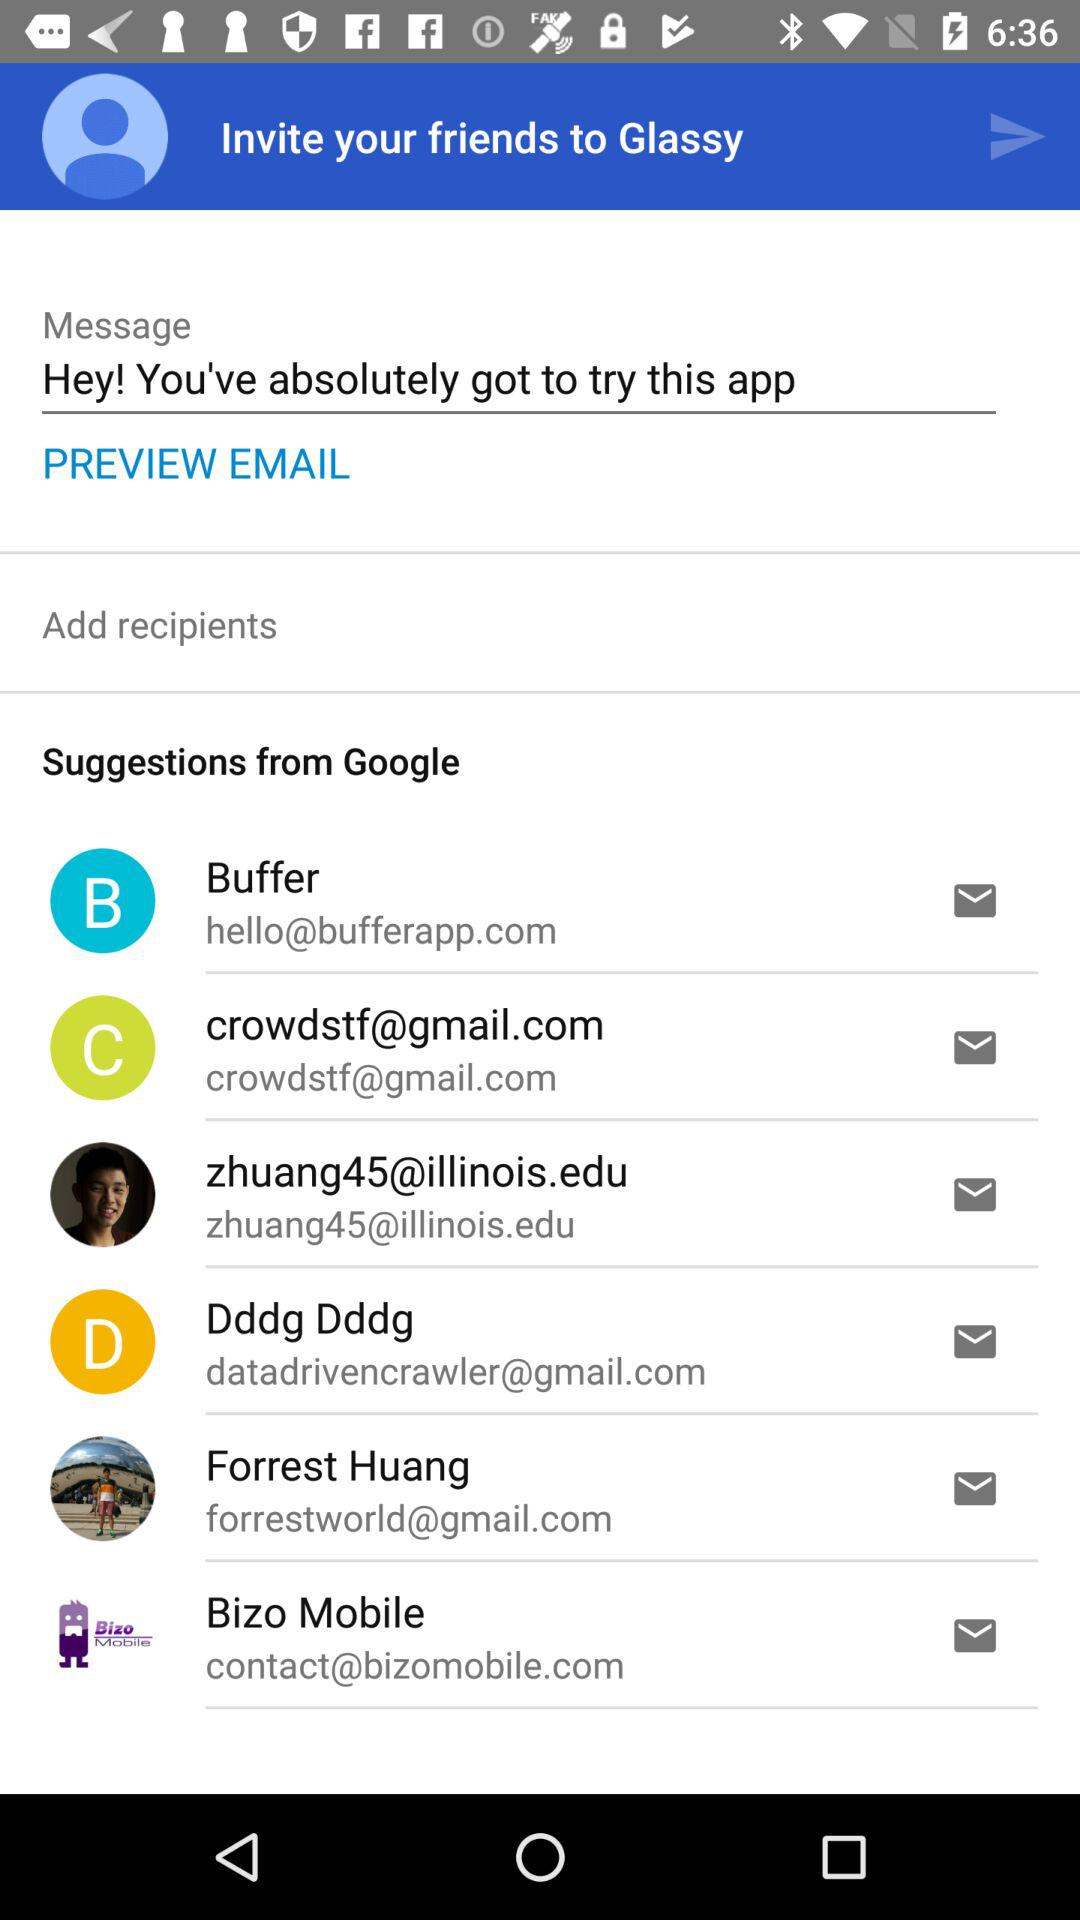What is the email address for the "Bizo Mobile"? The email address is contact@bizomobile.com. 